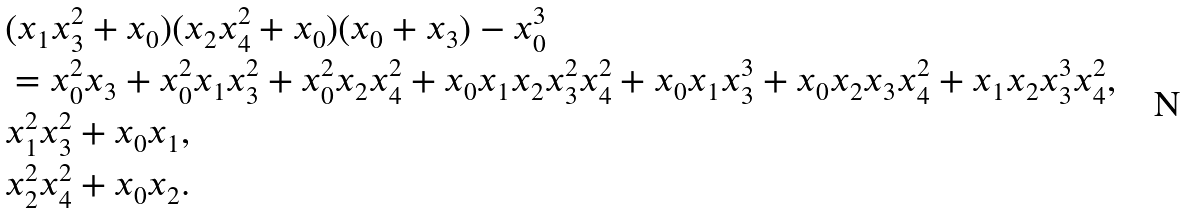<formula> <loc_0><loc_0><loc_500><loc_500>& ( x _ { 1 } x _ { 3 } ^ { 2 } + x _ { 0 } ) ( x _ { 2 } x _ { 4 } ^ { 2 } + x _ { 0 } ) ( x _ { 0 } + x _ { 3 } ) - x _ { 0 } ^ { 3 } \\ & = x _ { 0 } ^ { 2 } x _ { 3 } + x _ { 0 } ^ { 2 } x _ { 1 } x _ { 3 } ^ { 2 } + x _ { 0 } ^ { 2 } x _ { 2 } x _ { 4 } ^ { 2 } + x _ { 0 } x _ { 1 } x _ { 2 } x _ { 3 } ^ { 2 } x _ { 4 } ^ { 2 } + x _ { 0 } x _ { 1 } x _ { 3 } ^ { 3 } + x _ { 0 } x _ { 2 } x _ { 3 } x _ { 4 } ^ { 2 } + x _ { 1 } x _ { 2 } x _ { 3 } ^ { 3 } x _ { 4 } ^ { 2 } , \\ & x _ { 1 } ^ { 2 } x _ { 3 } ^ { 2 } + x _ { 0 } x _ { 1 } , \\ & x _ { 2 } ^ { 2 } x _ { 4 } ^ { 2 } + x _ { 0 } x _ { 2 } .</formula> 